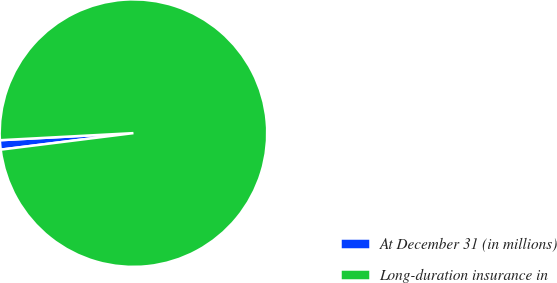Convert chart. <chart><loc_0><loc_0><loc_500><loc_500><pie_chart><fcel>At December 31 (in millions)<fcel>Long-duration insurance in<nl><fcel>1.13%<fcel>98.87%<nl></chart> 